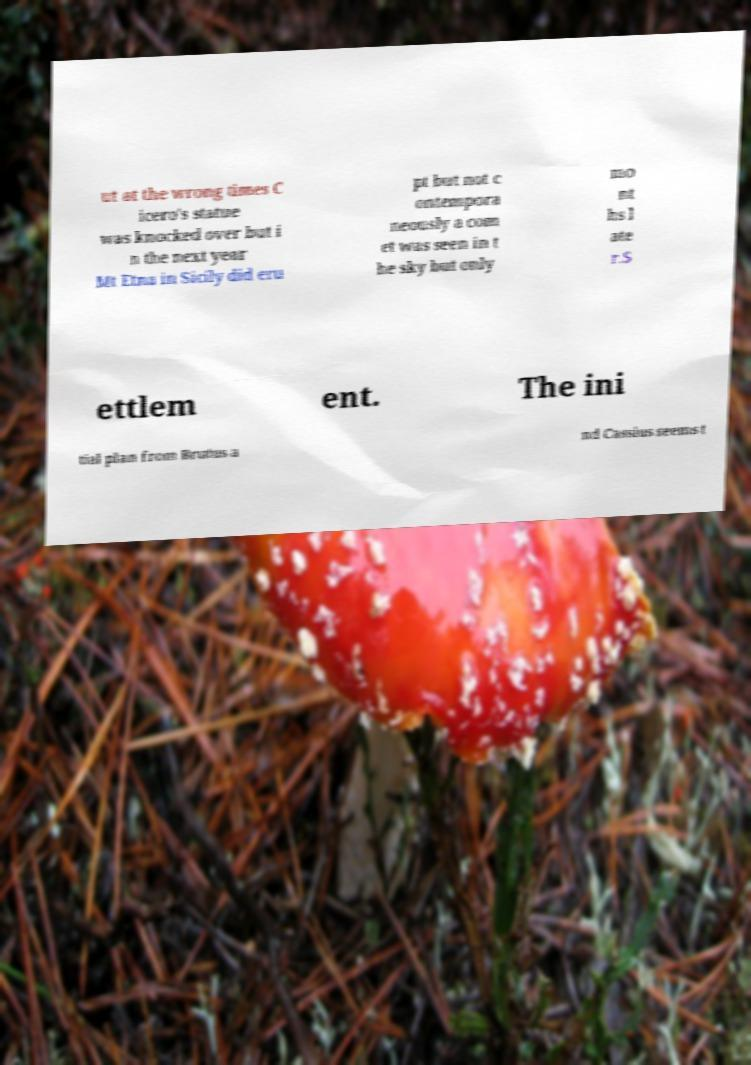Could you extract and type out the text from this image? ut at the wrong times C icero's statue was knocked over but i n the next year Mt Etna in Sicily did eru pt but not c ontempora neously a com et was seen in t he sky but only mo nt hs l ate r.S ettlem ent. The ini tial plan from Brutus a nd Cassius seems t 